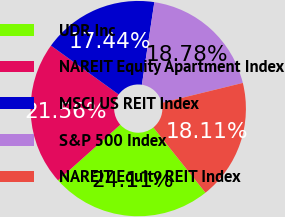Convert chart to OTSL. <chart><loc_0><loc_0><loc_500><loc_500><pie_chart><fcel>UDR Inc<fcel>NAREIT Equity Apartment Index<fcel>MSCI US REIT Index<fcel>S&P 500 Index<fcel>NAREIT Equity REIT Index<nl><fcel>24.11%<fcel>21.56%<fcel>17.44%<fcel>18.78%<fcel>18.11%<nl></chart> 